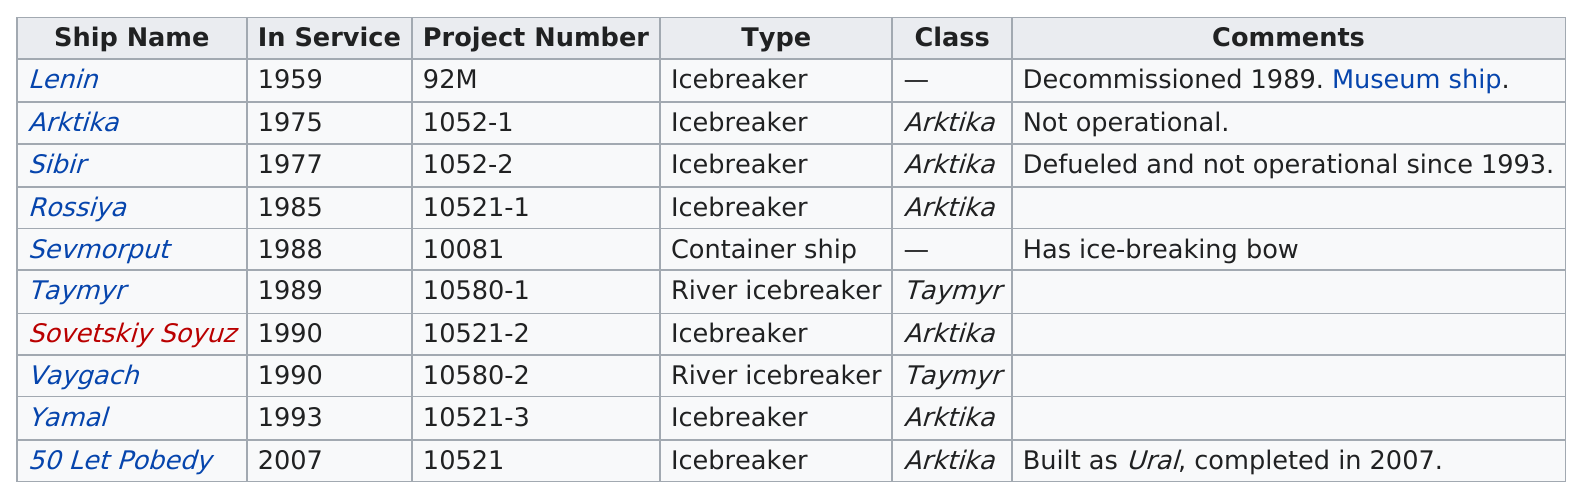Mention a couple of crucial points in this snapshot. The Sovetskiy Soyuz was commissioned for service in the same year as the Vaygach, which was a naval ship. The previous ship to travel to Siberia was the Arktika. What is the next ship after the Yamal? The 50 Let Pobedy.. The difference in years of service between the Taymyr and the Arktika is 14 years. The last ship in service was the 50 Let Pobedy. 